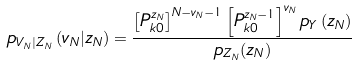Convert formula to latex. <formula><loc_0><loc_0><loc_500><loc_500>p _ { V _ { N } | Z _ { N } } \left ( v _ { N } | z _ { N } \right ) = \frac { \left [ P _ { k 0 } ^ { z _ { N } } \right ] ^ { N - v _ { N } - 1 } \left [ P _ { k 0 } ^ { z _ { N } - 1 } \right ] ^ { v _ { N } } p _ { Y } \left ( z _ { N } \right ) } { p _ { Z _ { N } } ( z _ { N } ) }</formula> 